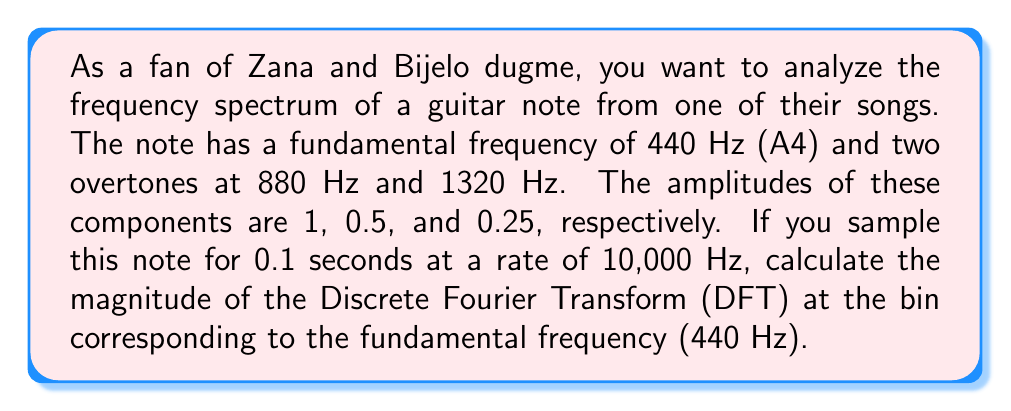What is the answer to this math problem? Let's approach this step-by-step:

1) First, we need to determine the number of samples:
   $$N = \text{sampling rate} \times \text{duration} = 10000 \times 0.1 = 1000\text{ samples}$$

2) The frequency resolution of the DFT is:
   $$\Delta f = \frac{\text{sampling rate}}{N} = \frac{10000}{1000} = 10\text{ Hz}$$

3) The bin corresponding to 440 Hz is:
   $$k = \frac{440\text{ Hz}}{10\text{ Hz}} = 44$$

4) The signal can be represented as:
   $$x(t) = \sin(2\pi 440t) + 0.5\sin(2\pi 880t) + 0.25\sin(2\pi 1320t)$$

5) The DFT of this signal at bin k is given by:
   $$X[k] = \sum_{n=0}^{N-1} x(n) e^{-j2\pi kn/N}$$

6) For a sinusoid with frequency $f$, amplitude $A$, and phase $\phi$, the magnitude of its DFT at its corresponding frequency bin is:
   $$|X[k]| = \frac{NA}{2}$$

7) In our case, we have three sinusoids. The one at 440 Hz contributes directly to bin 44, while the others contribute to different bins.

8) Therefore, the magnitude at bin 44 is primarily due to the 440 Hz component:
   $$|X[44]| = \frac{N \times 1}{2} = \frac{1000}{2} = 500$$
Answer: The magnitude of the DFT at the bin corresponding to 440 Hz is 500. 